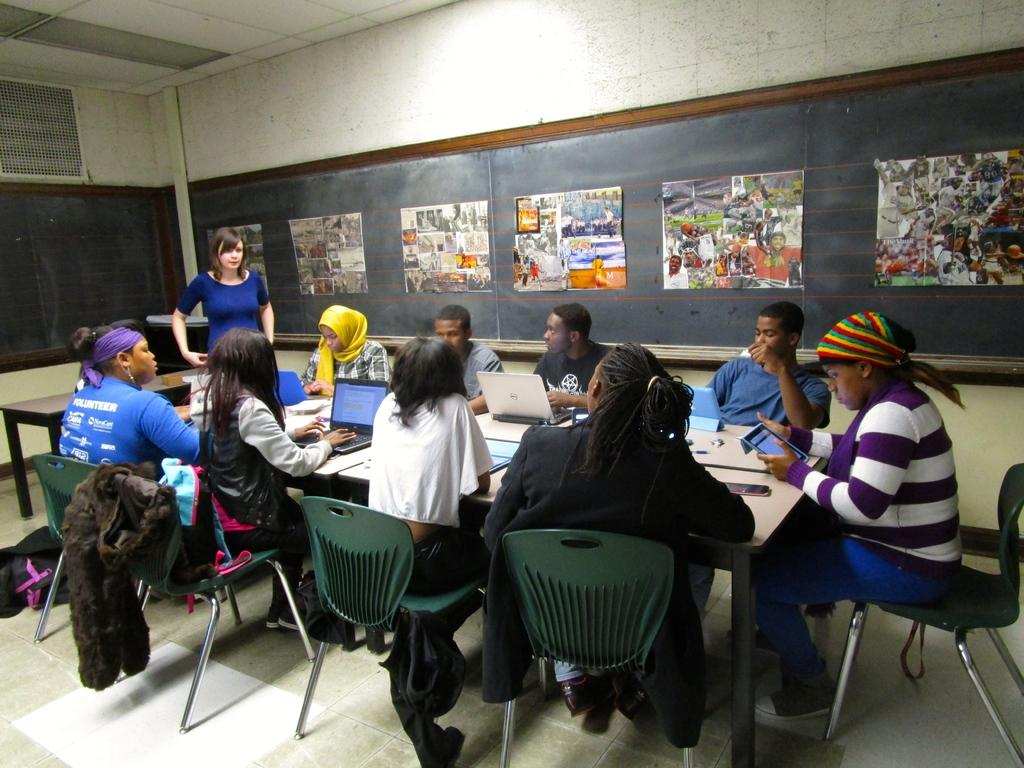What are the people in the image doing? The people in the image are sitting on chairs. How are the chairs arranged in the image? The chairs are arranged around a table. What electronic devices can be seen in the image? There are laptops in the image. What type of writing surface is present in the image? There are blackboards with charts in the image. What type of carriage can be seen in the image? There is no carriage present in the image. How does the loss of the quarter affect the people in the image? There is no mention of a quarter or any loss in the image. 